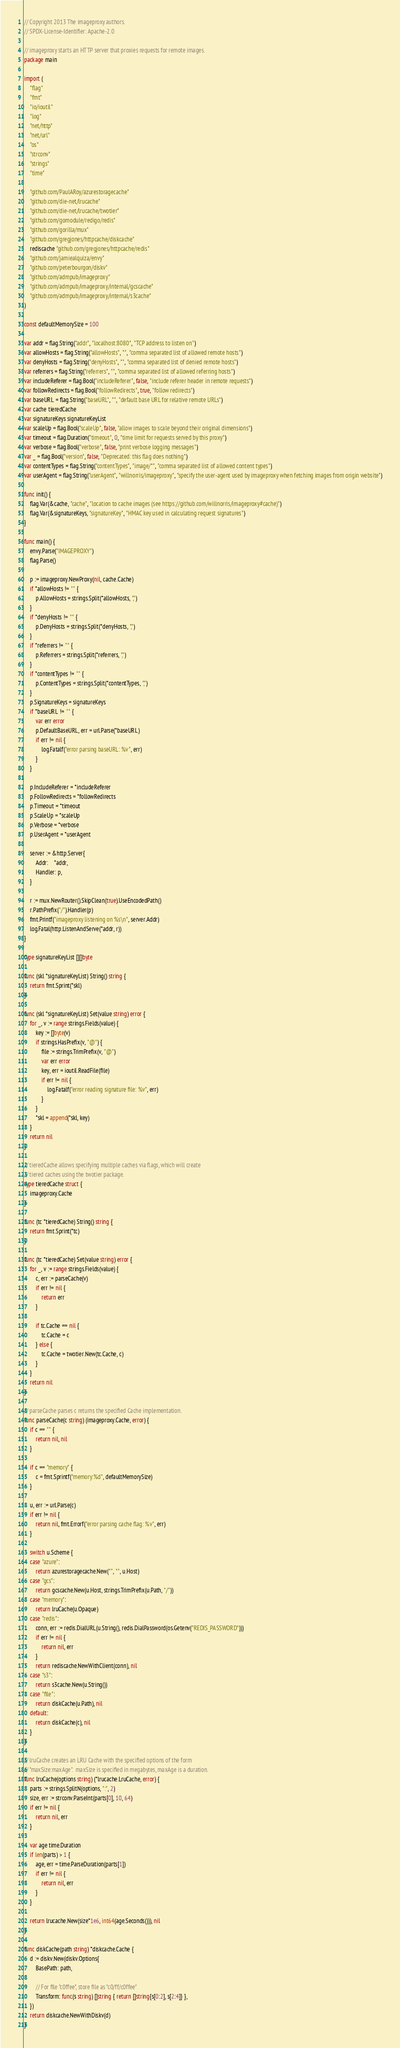<code> <loc_0><loc_0><loc_500><loc_500><_Go_>// Copyright 2013 The imageproxy authors.
// SPDX-License-Identifier: Apache-2.0

// imageproxy starts an HTTP server that proxies requests for remote images.
package main

import (
	"flag"
	"fmt"
	"io/ioutil"
	"log"
	"net/http"
	"net/url"
	"os"
	"strconv"
	"strings"
	"time"

	"github.com/PaulARoy/azurestoragecache"
	"github.com/die-net/lrucache"
	"github.com/die-net/lrucache/twotier"
	"github.com/gomodule/redigo/redis"
	"github.com/gorilla/mux"
	"github.com/gregjones/httpcache/diskcache"
	rediscache "github.com/gregjones/httpcache/redis"
	"github.com/jamiealquiza/envy"
	"github.com/peterbourgon/diskv"
	"github.com/admpub/imageproxy"
	"github.com/admpub/imageproxy/internal/gcscache"
	"github.com/admpub/imageproxy/internal/s3cache"
)

const defaultMemorySize = 100

var addr = flag.String("addr", "localhost:8080", "TCP address to listen on")
var allowHosts = flag.String("allowHosts", "", "comma separated list of allowed remote hosts")
var denyHosts = flag.String("denyHosts", "", "comma separated list of denied remote hosts")
var referrers = flag.String("referrers", "", "comma separated list of allowed referring hosts")
var includeReferer = flag.Bool("includeReferer", false, "include referer header in remote requests")
var followRedirects = flag.Bool("followRedirects", true, "follow redirects")
var baseURL = flag.String("baseURL", "", "default base URL for relative remote URLs")
var cache tieredCache
var signatureKeys signatureKeyList
var scaleUp = flag.Bool("scaleUp", false, "allow images to scale beyond their original dimensions")
var timeout = flag.Duration("timeout", 0, "time limit for requests served by this proxy")
var verbose = flag.Bool("verbose", false, "print verbose logging messages")
var _ = flag.Bool("version", false, "Deprecated: this flag does nothing")
var contentTypes = flag.String("contentTypes", "image/*", "comma separated list of allowed content types")
var userAgent = flag.String("userAgent", "willnorris/imageproxy", "specify the user-agent used by imageproxy when fetching images from origin website")

func init() {
	flag.Var(&cache, "cache", "location to cache images (see https://github.com/willnorris/imageproxy#cache)")
	flag.Var(&signatureKeys, "signatureKey", "HMAC key used in calculating request signatures")
}

func main() {
	envy.Parse("IMAGEPROXY")
	flag.Parse()

	p := imageproxy.NewProxy(nil, cache.Cache)
	if *allowHosts != "" {
		p.AllowHosts = strings.Split(*allowHosts, ",")
	}
	if *denyHosts != "" {
		p.DenyHosts = strings.Split(*denyHosts, ",")
	}
	if *referrers != "" {
		p.Referrers = strings.Split(*referrers, ",")
	}
	if *contentTypes != "" {
		p.ContentTypes = strings.Split(*contentTypes, ",")
	}
	p.SignatureKeys = signatureKeys
	if *baseURL != "" {
		var err error
		p.DefaultBaseURL, err = url.Parse(*baseURL)
		if err != nil {
			log.Fatalf("error parsing baseURL: %v", err)
		}
	}

	p.IncludeReferer = *includeReferer
	p.FollowRedirects = *followRedirects
	p.Timeout = *timeout
	p.ScaleUp = *scaleUp
	p.Verbose = *verbose
	p.UserAgent = *userAgent

	server := &http.Server{
		Addr:    *addr,
		Handler: p,
	}

	r := mux.NewRouter().SkipClean(true).UseEncodedPath()
	r.PathPrefix("/").Handler(p)
	fmt.Printf("imageproxy listening on %s\n", server.Addr)
	log.Fatal(http.ListenAndServe(*addr, r))
}

type signatureKeyList [][]byte

func (skl *signatureKeyList) String() string {
	return fmt.Sprint(*skl)
}

func (skl *signatureKeyList) Set(value string) error {
	for _, v := range strings.Fields(value) {
		key := []byte(v)
		if strings.HasPrefix(v, "@") {
			file := strings.TrimPrefix(v, "@")
			var err error
			key, err = ioutil.ReadFile(file)
			if err != nil {
				log.Fatalf("error reading signature file: %v", err)
			}
		}
		*skl = append(*skl, key)
	}
	return nil
}

// tieredCache allows specifying multiple caches via flags, which will create
// tiered caches using the twotier package.
type tieredCache struct {
	imageproxy.Cache
}

func (tc *tieredCache) String() string {
	return fmt.Sprint(*tc)
}

func (tc *tieredCache) Set(value string) error {
	for _, v := range strings.Fields(value) {
		c, err := parseCache(v)
		if err != nil {
			return err
		}

		if tc.Cache == nil {
			tc.Cache = c
		} else {
			tc.Cache = twotier.New(tc.Cache, c)
		}
	}
	return nil
}

// parseCache parses c returns the specified Cache implementation.
func parseCache(c string) (imageproxy.Cache, error) {
	if c == "" {
		return nil, nil
	}

	if c == "memory" {
		c = fmt.Sprintf("memory:%d", defaultMemorySize)
	}

	u, err := url.Parse(c)
	if err != nil {
		return nil, fmt.Errorf("error parsing cache flag: %v", err)
	}

	switch u.Scheme {
	case "azure":
		return azurestoragecache.New("", "", u.Host)
	case "gcs":
		return gcscache.New(u.Host, strings.TrimPrefix(u.Path, "/"))
	case "memory":
		return lruCache(u.Opaque)
	case "redis":
		conn, err := redis.DialURL(u.String(), redis.DialPassword(os.Getenv("REDIS_PASSWORD")))
		if err != nil {
			return nil, err
		}
		return rediscache.NewWithClient(conn), nil
	case "s3":
		return s3cache.New(u.String())
	case "file":
		return diskCache(u.Path), nil
	default:
		return diskCache(c), nil
	}
}

// lruCache creates an LRU Cache with the specified options of the form
// "maxSize:maxAge".  maxSize is specified in megabytes, maxAge is a duration.
func lruCache(options string) (*lrucache.LruCache, error) {
	parts := strings.SplitN(options, ":", 2)
	size, err := strconv.ParseInt(parts[0], 10, 64)
	if err != nil {
		return nil, err
	}

	var age time.Duration
	if len(parts) > 1 {
		age, err = time.ParseDuration(parts[1])
		if err != nil {
			return nil, err
		}
	}

	return lrucache.New(size*1e6, int64(age.Seconds())), nil
}

func diskCache(path string) *diskcache.Cache {
	d := diskv.New(diskv.Options{
		BasePath: path,

		// For file "c0ffee", store file as "c0/ff/c0ffee"
		Transform: func(s string) []string { return []string{s[0:2], s[2:4]} },
	})
	return diskcache.NewWithDiskv(d)
}
</code> 